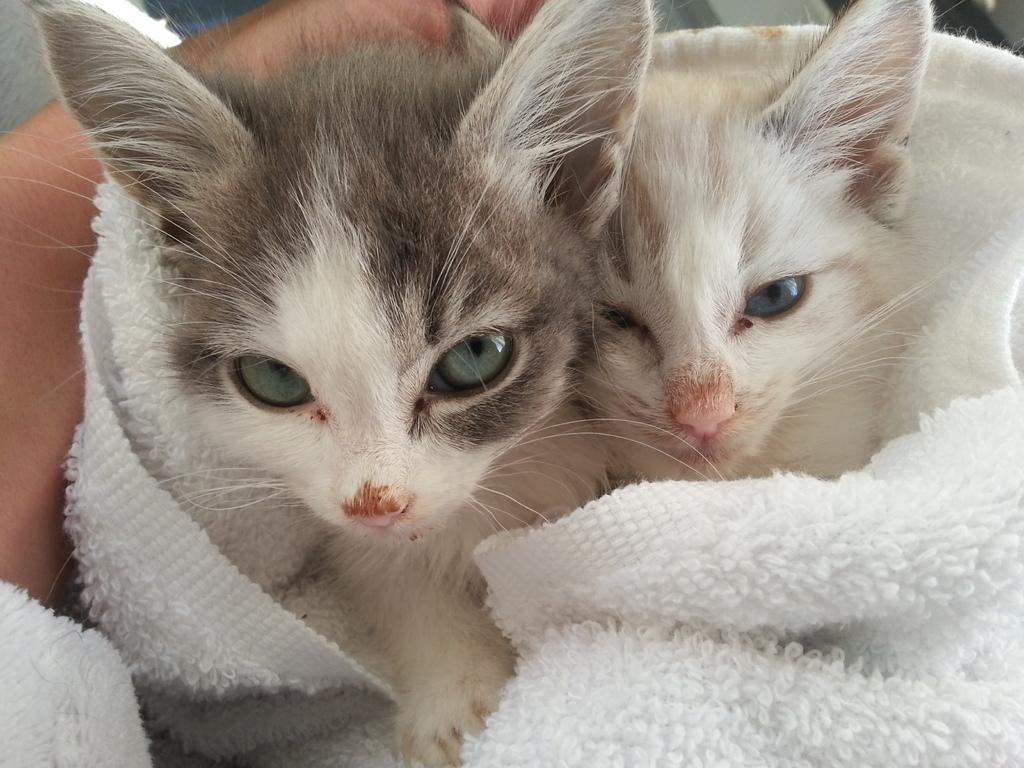How many cats are visible in the image? There are two cats in the image. What is the condition of the cats in the image? The cats are wrapped in a cloth. Where are the cats located in the image? The cats are in the foreground of the image. What else can be seen on the left side of the image? There is a person's hand on the left side of the image. What type of organization is responsible for the minute in the image? There is no minute or organization present in the image; it features two cats wrapped in a cloth. How does the cork interact with the cats in the image? There is no cork present in the image, so it cannot interact with the cats. 